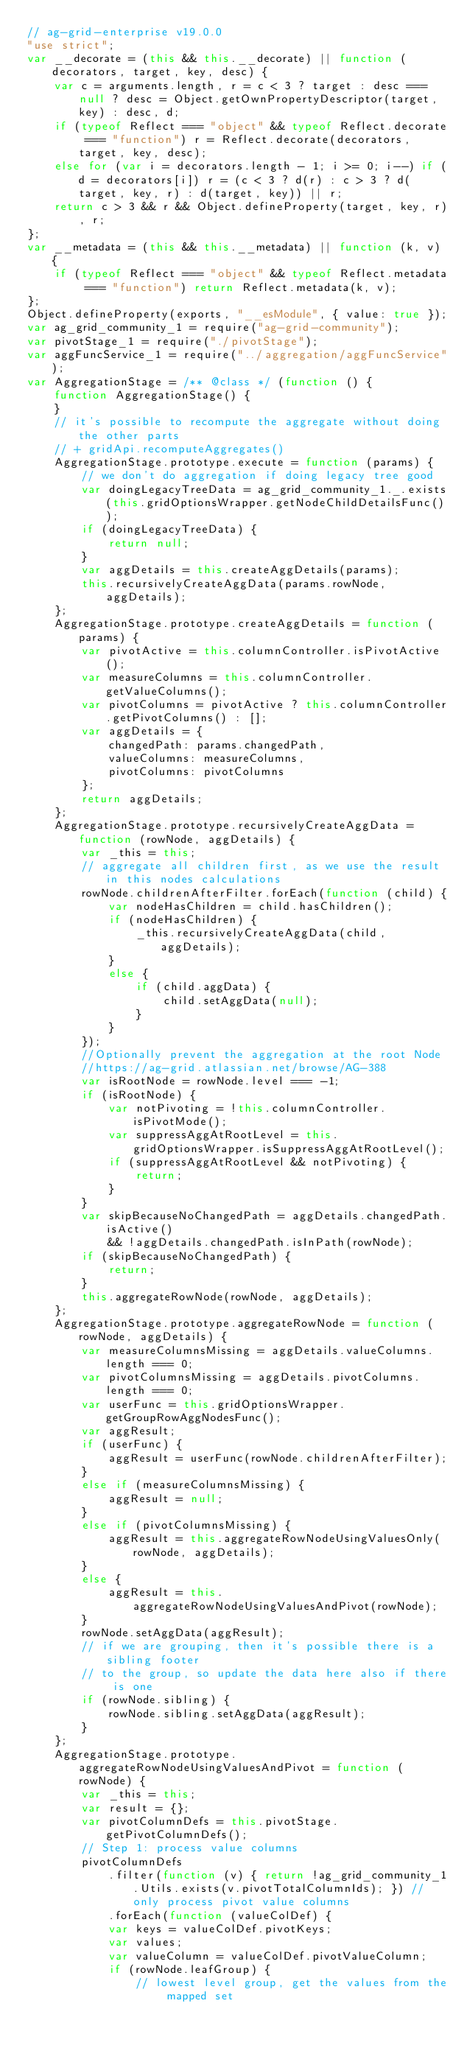<code> <loc_0><loc_0><loc_500><loc_500><_JavaScript_>// ag-grid-enterprise v19.0.0
"use strict";
var __decorate = (this && this.__decorate) || function (decorators, target, key, desc) {
    var c = arguments.length, r = c < 3 ? target : desc === null ? desc = Object.getOwnPropertyDescriptor(target, key) : desc, d;
    if (typeof Reflect === "object" && typeof Reflect.decorate === "function") r = Reflect.decorate(decorators, target, key, desc);
    else for (var i = decorators.length - 1; i >= 0; i--) if (d = decorators[i]) r = (c < 3 ? d(r) : c > 3 ? d(target, key, r) : d(target, key)) || r;
    return c > 3 && r && Object.defineProperty(target, key, r), r;
};
var __metadata = (this && this.__metadata) || function (k, v) {
    if (typeof Reflect === "object" && typeof Reflect.metadata === "function") return Reflect.metadata(k, v);
};
Object.defineProperty(exports, "__esModule", { value: true });
var ag_grid_community_1 = require("ag-grid-community");
var pivotStage_1 = require("./pivotStage");
var aggFuncService_1 = require("../aggregation/aggFuncService");
var AggregationStage = /** @class */ (function () {
    function AggregationStage() {
    }
    // it's possible to recompute the aggregate without doing the other parts
    // + gridApi.recomputeAggregates()
    AggregationStage.prototype.execute = function (params) {
        // we don't do aggregation if doing legacy tree good
        var doingLegacyTreeData = ag_grid_community_1._.exists(this.gridOptionsWrapper.getNodeChildDetailsFunc());
        if (doingLegacyTreeData) {
            return null;
        }
        var aggDetails = this.createAggDetails(params);
        this.recursivelyCreateAggData(params.rowNode, aggDetails);
    };
    AggregationStage.prototype.createAggDetails = function (params) {
        var pivotActive = this.columnController.isPivotActive();
        var measureColumns = this.columnController.getValueColumns();
        var pivotColumns = pivotActive ? this.columnController.getPivotColumns() : [];
        var aggDetails = {
            changedPath: params.changedPath,
            valueColumns: measureColumns,
            pivotColumns: pivotColumns
        };
        return aggDetails;
    };
    AggregationStage.prototype.recursivelyCreateAggData = function (rowNode, aggDetails) {
        var _this = this;
        // aggregate all children first, as we use the result in this nodes calculations
        rowNode.childrenAfterFilter.forEach(function (child) {
            var nodeHasChildren = child.hasChildren();
            if (nodeHasChildren) {
                _this.recursivelyCreateAggData(child, aggDetails);
            }
            else {
                if (child.aggData) {
                    child.setAggData(null);
                }
            }
        });
        //Optionally prevent the aggregation at the root Node
        //https://ag-grid.atlassian.net/browse/AG-388
        var isRootNode = rowNode.level === -1;
        if (isRootNode) {
            var notPivoting = !this.columnController.isPivotMode();
            var suppressAggAtRootLevel = this.gridOptionsWrapper.isSuppressAggAtRootLevel();
            if (suppressAggAtRootLevel && notPivoting) {
                return;
            }
        }
        var skipBecauseNoChangedPath = aggDetails.changedPath.isActive()
            && !aggDetails.changedPath.isInPath(rowNode);
        if (skipBecauseNoChangedPath) {
            return;
        }
        this.aggregateRowNode(rowNode, aggDetails);
    };
    AggregationStage.prototype.aggregateRowNode = function (rowNode, aggDetails) {
        var measureColumnsMissing = aggDetails.valueColumns.length === 0;
        var pivotColumnsMissing = aggDetails.pivotColumns.length === 0;
        var userFunc = this.gridOptionsWrapper.getGroupRowAggNodesFunc();
        var aggResult;
        if (userFunc) {
            aggResult = userFunc(rowNode.childrenAfterFilter);
        }
        else if (measureColumnsMissing) {
            aggResult = null;
        }
        else if (pivotColumnsMissing) {
            aggResult = this.aggregateRowNodeUsingValuesOnly(rowNode, aggDetails);
        }
        else {
            aggResult = this.aggregateRowNodeUsingValuesAndPivot(rowNode);
        }
        rowNode.setAggData(aggResult);
        // if we are grouping, then it's possible there is a sibling footer
        // to the group, so update the data here also if there is one
        if (rowNode.sibling) {
            rowNode.sibling.setAggData(aggResult);
        }
    };
    AggregationStage.prototype.aggregateRowNodeUsingValuesAndPivot = function (rowNode) {
        var _this = this;
        var result = {};
        var pivotColumnDefs = this.pivotStage.getPivotColumnDefs();
        // Step 1: process value columns
        pivotColumnDefs
            .filter(function (v) { return !ag_grid_community_1.Utils.exists(v.pivotTotalColumnIds); }) // only process pivot value columns
            .forEach(function (valueColDef) {
            var keys = valueColDef.pivotKeys;
            var values;
            var valueColumn = valueColDef.pivotValueColumn;
            if (rowNode.leafGroup) {
                // lowest level group, get the values from the mapped set</code> 